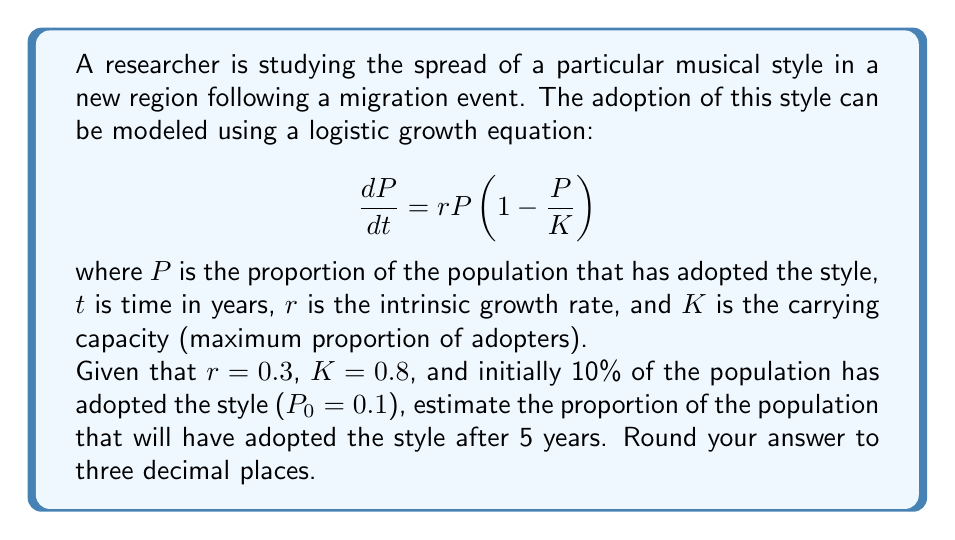Solve this math problem. To solve this problem, we need to use the solution to the logistic growth equation:

$$P(t) = \frac{K}{1 + (\frac{K}{P_0} - 1)e^{-rt}}$$

Let's follow these steps:

1) We are given:
   $r = 0.3$
   $K = 0.8$
   $P_0 = 0.1$
   $t = 5$

2) Substitute these values into the equation:

   $$P(5) = \frac{0.8}{1 + (\frac{0.8}{0.1} - 1)e^{-0.3(5)}}$$

3) Simplify the fraction inside the parentheses:

   $$P(5) = \frac{0.8}{1 + (8 - 1)e^{-1.5}}$$

4) Calculate $e^{-1.5}$:

   $$P(5) = \frac{0.8}{1 + 7(0.2231)}$$

5) Multiply:

   $$P(5) = \frac{0.8}{1 + 1.5617}$$

6) Add in the denominator:

   $$P(5) = \frac{0.8}{2.5617}$$

7) Divide:

   $$P(5) = 0.3123$$

8) Round to three decimal places:

   $$P(5) \approx 0.312$$
Answer: 0.312 